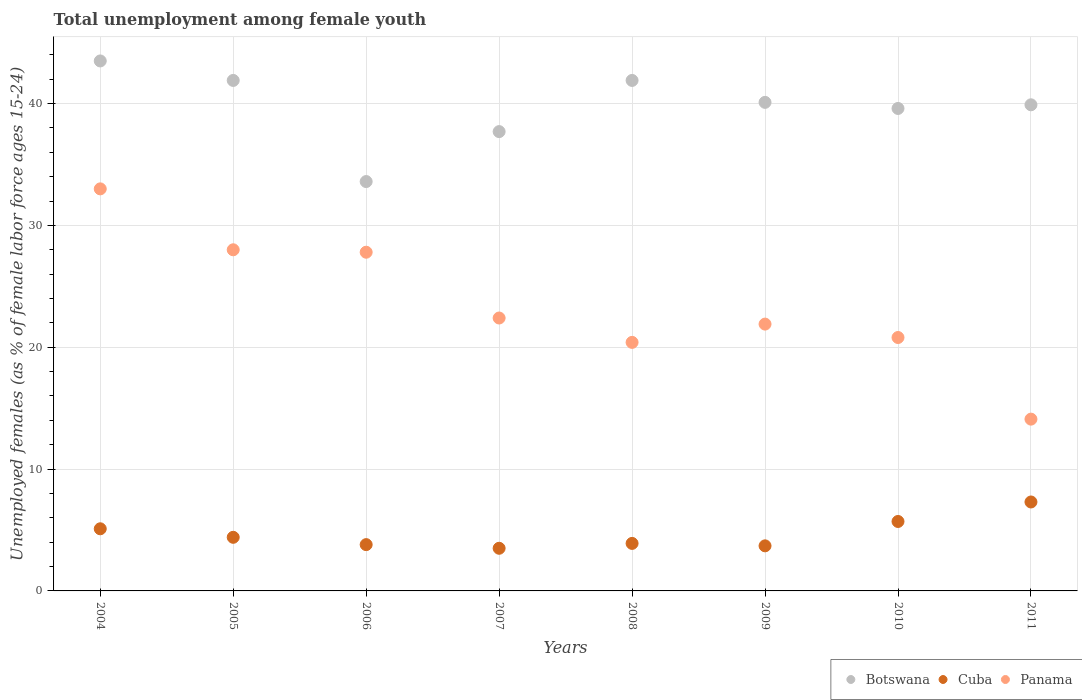How many different coloured dotlines are there?
Make the answer very short. 3. What is the percentage of unemployed females in in Cuba in 2011?
Make the answer very short. 7.3. In which year was the percentage of unemployed females in in Panama maximum?
Make the answer very short. 2004. What is the total percentage of unemployed females in in Panama in the graph?
Make the answer very short. 188.4. What is the difference between the percentage of unemployed females in in Cuba in 2004 and that in 2010?
Your answer should be very brief. -0.6. What is the difference between the percentage of unemployed females in in Cuba in 2009 and the percentage of unemployed females in in Panama in 2008?
Keep it short and to the point. -16.7. What is the average percentage of unemployed females in in Panama per year?
Offer a very short reply. 23.55. In the year 2006, what is the difference between the percentage of unemployed females in in Panama and percentage of unemployed females in in Botswana?
Provide a short and direct response. -5.8. In how many years, is the percentage of unemployed females in in Panama greater than 10 %?
Provide a succinct answer. 8. What is the ratio of the percentage of unemployed females in in Botswana in 2009 to that in 2010?
Provide a short and direct response. 1.01. Is the percentage of unemployed females in in Panama in 2007 less than that in 2009?
Offer a terse response. No. What is the difference between the highest and the second highest percentage of unemployed females in in Cuba?
Your answer should be very brief. 1.6. What is the difference between the highest and the lowest percentage of unemployed females in in Cuba?
Your answer should be very brief. 3.8. Is the sum of the percentage of unemployed females in in Botswana in 2006 and 2010 greater than the maximum percentage of unemployed females in in Panama across all years?
Provide a short and direct response. Yes. Does the percentage of unemployed females in in Botswana monotonically increase over the years?
Offer a very short reply. No. Is the percentage of unemployed females in in Botswana strictly greater than the percentage of unemployed females in in Panama over the years?
Make the answer very short. Yes. Is the percentage of unemployed females in in Panama strictly less than the percentage of unemployed females in in Botswana over the years?
Provide a succinct answer. Yes. How many dotlines are there?
Keep it short and to the point. 3. How many years are there in the graph?
Your answer should be compact. 8. Are the values on the major ticks of Y-axis written in scientific E-notation?
Your answer should be very brief. No. Does the graph contain any zero values?
Your answer should be very brief. No. Where does the legend appear in the graph?
Provide a short and direct response. Bottom right. How many legend labels are there?
Your response must be concise. 3. How are the legend labels stacked?
Ensure brevity in your answer.  Horizontal. What is the title of the graph?
Your response must be concise. Total unemployment among female youth. What is the label or title of the X-axis?
Ensure brevity in your answer.  Years. What is the label or title of the Y-axis?
Ensure brevity in your answer.  Unemployed females (as % of female labor force ages 15-24). What is the Unemployed females (as % of female labor force ages 15-24) of Botswana in 2004?
Ensure brevity in your answer.  43.5. What is the Unemployed females (as % of female labor force ages 15-24) of Cuba in 2004?
Your answer should be very brief. 5.1. What is the Unemployed females (as % of female labor force ages 15-24) in Panama in 2004?
Provide a succinct answer. 33. What is the Unemployed females (as % of female labor force ages 15-24) in Botswana in 2005?
Give a very brief answer. 41.9. What is the Unemployed females (as % of female labor force ages 15-24) in Cuba in 2005?
Your answer should be very brief. 4.4. What is the Unemployed females (as % of female labor force ages 15-24) in Panama in 2005?
Your answer should be compact. 28. What is the Unemployed females (as % of female labor force ages 15-24) of Botswana in 2006?
Your answer should be compact. 33.6. What is the Unemployed females (as % of female labor force ages 15-24) in Cuba in 2006?
Give a very brief answer. 3.8. What is the Unemployed females (as % of female labor force ages 15-24) of Panama in 2006?
Make the answer very short. 27.8. What is the Unemployed females (as % of female labor force ages 15-24) of Botswana in 2007?
Offer a terse response. 37.7. What is the Unemployed females (as % of female labor force ages 15-24) of Panama in 2007?
Make the answer very short. 22.4. What is the Unemployed females (as % of female labor force ages 15-24) in Botswana in 2008?
Ensure brevity in your answer.  41.9. What is the Unemployed females (as % of female labor force ages 15-24) in Cuba in 2008?
Your answer should be very brief. 3.9. What is the Unemployed females (as % of female labor force ages 15-24) of Panama in 2008?
Give a very brief answer. 20.4. What is the Unemployed females (as % of female labor force ages 15-24) of Botswana in 2009?
Your response must be concise. 40.1. What is the Unemployed females (as % of female labor force ages 15-24) in Cuba in 2009?
Provide a short and direct response. 3.7. What is the Unemployed females (as % of female labor force ages 15-24) of Panama in 2009?
Make the answer very short. 21.9. What is the Unemployed females (as % of female labor force ages 15-24) in Botswana in 2010?
Provide a succinct answer. 39.6. What is the Unemployed females (as % of female labor force ages 15-24) in Cuba in 2010?
Provide a succinct answer. 5.7. What is the Unemployed females (as % of female labor force ages 15-24) in Panama in 2010?
Your response must be concise. 20.8. What is the Unemployed females (as % of female labor force ages 15-24) of Botswana in 2011?
Keep it short and to the point. 39.9. What is the Unemployed females (as % of female labor force ages 15-24) in Cuba in 2011?
Offer a terse response. 7.3. What is the Unemployed females (as % of female labor force ages 15-24) of Panama in 2011?
Provide a short and direct response. 14.1. Across all years, what is the maximum Unemployed females (as % of female labor force ages 15-24) in Botswana?
Your answer should be very brief. 43.5. Across all years, what is the maximum Unemployed females (as % of female labor force ages 15-24) of Cuba?
Give a very brief answer. 7.3. Across all years, what is the maximum Unemployed females (as % of female labor force ages 15-24) of Panama?
Your answer should be compact. 33. Across all years, what is the minimum Unemployed females (as % of female labor force ages 15-24) in Botswana?
Your response must be concise. 33.6. Across all years, what is the minimum Unemployed females (as % of female labor force ages 15-24) of Panama?
Give a very brief answer. 14.1. What is the total Unemployed females (as % of female labor force ages 15-24) of Botswana in the graph?
Keep it short and to the point. 318.2. What is the total Unemployed females (as % of female labor force ages 15-24) in Cuba in the graph?
Your response must be concise. 37.4. What is the total Unemployed females (as % of female labor force ages 15-24) of Panama in the graph?
Your answer should be very brief. 188.4. What is the difference between the Unemployed females (as % of female labor force ages 15-24) in Panama in 2004 and that in 2005?
Keep it short and to the point. 5. What is the difference between the Unemployed females (as % of female labor force ages 15-24) of Botswana in 2004 and that in 2006?
Your response must be concise. 9.9. What is the difference between the Unemployed females (as % of female labor force ages 15-24) in Cuba in 2004 and that in 2006?
Give a very brief answer. 1.3. What is the difference between the Unemployed females (as % of female labor force ages 15-24) in Botswana in 2004 and that in 2007?
Give a very brief answer. 5.8. What is the difference between the Unemployed females (as % of female labor force ages 15-24) in Cuba in 2004 and that in 2007?
Provide a short and direct response. 1.6. What is the difference between the Unemployed females (as % of female labor force ages 15-24) in Botswana in 2004 and that in 2008?
Offer a very short reply. 1.6. What is the difference between the Unemployed females (as % of female labor force ages 15-24) in Panama in 2004 and that in 2008?
Your answer should be very brief. 12.6. What is the difference between the Unemployed females (as % of female labor force ages 15-24) in Cuba in 2004 and that in 2009?
Your response must be concise. 1.4. What is the difference between the Unemployed females (as % of female labor force ages 15-24) of Cuba in 2004 and that in 2010?
Provide a short and direct response. -0.6. What is the difference between the Unemployed females (as % of female labor force ages 15-24) of Panama in 2004 and that in 2010?
Give a very brief answer. 12.2. What is the difference between the Unemployed females (as % of female labor force ages 15-24) of Botswana in 2004 and that in 2011?
Your response must be concise. 3.6. What is the difference between the Unemployed females (as % of female labor force ages 15-24) in Panama in 2005 and that in 2006?
Provide a succinct answer. 0.2. What is the difference between the Unemployed females (as % of female labor force ages 15-24) of Cuba in 2005 and that in 2007?
Keep it short and to the point. 0.9. What is the difference between the Unemployed females (as % of female labor force ages 15-24) in Panama in 2005 and that in 2007?
Ensure brevity in your answer.  5.6. What is the difference between the Unemployed females (as % of female labor force ages 15-24) of Cuba in 2005 and that in 2009?
Ensure brevity in your answer.  0.7. What is the difference between the Unemployed females (as % of female labor force ages 15-24) of Panama in 2005 and that in 2009?
Provide a succinct answer. 6.1. What is the difference between the Unemployed females (as % of female labor force ages 15-24) of Cuba in 2005 and that in 2010?
Keep it short and to the point. -1.3. What is the difference between the Unemployed females (as % of female labor force ages 15-24) in Panama in 2005 and that in 2010?
Your answer should be very brief. 7.2. What is the difference between the Unemployed females (as % of female labor force ages 15-24) in Botswana in 2005 and that in 2011?
Your answer should be very brief. 2. What is the difference between the Unemployed females (as % of female labor force ages 15-24) in Panama in 2005 and that in 2011?
Provide a short and direct response. 13.9. What is the difference between the Unemployed females (as % of female labor force ages 15-24) of Botswana in 2006 and that in 2007?
Make the answer very short. -4.1. What is the difference between the Unemployed females (as % of female labor force ages 15-24) of Cuba in 2006 and that in 2007?
Make the answer very short. 0.3. What is the difference between the Unemployed females (as % of female labor force ages 15-24) in Botswana in 2006 and that in 2008?
Give a very brief answer. -8.3. What is the difference between the Unemployed females (as % of female labor force ages 15-24) in Panama in 2006 and that in 2008?
Make the answer very short. 7.4. What is the difference between the Unemployed females (as % of female labor force ages 15-24) in Panama in 2006 and that in 2009?
Make the answer very short. 5.9. What is the difference between the Unemployed females (as % of female labor force ages 15-24) of Cuba in 2006 and that in 2010?
Offer a terse response. -1.9. What is the difference between the Unemployed females (as % of female labor force ages 15-24) in Panama in 2006 and that in 2010?
Ensure brevity in your answer.  7. What is the difference between the Unemployed females (as % of female labor force ages 15-24) of Cuba in 2006 and that in 2011?
Ensure brevity in your answer.  -3.5. What is the difference between the Unemployed females (as % of female labor force ages 15-24) of Panama in 2006 and that in 2011?
Offer a terse response. 13.7. What is the difference between the Unemployed females (as % of female labor force ages 15-24) of Botswana in 2007 and that in 2008?
Offer a very short reply. -4.2. What is the difference between the Unemployed females (as % of female labor force ages 15-24) of Cuba in 2007 and that in 2008?
Your response must be concise. -0.4. What is the difference between the Unemployed females (as % of female labor force ages 15-24) in Botswana in 2007 and that in 2009?
Your answer should be very brief. -2.4. What is the difference between the Unemployed females (as % of female labor force ages 15-24) of Cuba in 2007 and that in 2009?
Offer a very short reply. -0.2. What is the difference between the Unemployed females (as % of female labor force ages 15-24) in Panama in 2007 and that in 2010?
Give a very brief answer. 1.6. What is the difference between the Unemployed females (as % of female labor force ages 15-24) of Botswana in 2007 and that in 2011?
Make the answer very short. -2.2. What is the difference between the Unemployed females (as % of female labor force ages 15-24) of Cuba in 2007 and that in 2011?
Your response must be concise. -3.8. What is the difference between the Unemployed females (as % of female labor force ages 15-24) of Botswana in 2008 and that in 2009?
Make the answer very short. 1.8. What is the difference between the Unemployed females (as % of female labor force ages 15-24) in Cuba in 2008 and that in 2009?
Provide a succinct answer. 0.2. What is the difference between the Unemployed females (as % of female labor force ages 15-24) in Panama in 2008 and that in 2009?
Offer a terse response. -1.5. What is the difference between the Unemployed females (as % of female labor force ages 15-24) in Botswana in 2008 and that in 2010?
Make the answer very short. 2.3. What is the difference between the Unemployed females (as % of female labor force ages 15-24) in Cuba in 2008 and that in 2011?
Ensure brevity in your answer.  -3.4. What is the difference between the Unemployed females (as % of female labor force ages 15-24) in Panama in 2008 and that in 2011?
Ensure brevity in your answer.  6.3. What is the difference between the Unemployed females (as % of female labor force ages 15-24) in Botswana in 2009 and that in 2010?
Provide a short and direct response. 0.5. What is the difference between the Unemployed females (as % of female labor force ages 15-24) of Cuba in 2009 and that in 2010?
Provide a short and direct response. -2. What is the difference between the Unemployed females (as % of female labor force ages 15-24) in Panama in 2009 and that in 2010?
Offer a very short reply. 1.1. What is the difference between the Unemployed females (as % of female labor force ages 15-24) in Botswana in 2009 and that in 2011?
Keep it short and to the point. 0.2. What is the difference between the Unemployed females (as % of female labor force ages 15-24) in Cuba in 2009 and that in 2011?
Ensure brevity in your answer.  -3.6. What is the difference between the Unemployed females (as % of female labor force ages 15-24) in Panama in 2009 and that in 2011?
Provide a short and direct response. 7.8. What is the difference between the Unemployed females (as % of female labor force ages 15-24) in Botswana in 2004 and the Unemployed females (as % of female labor force ages 15-24) in Cuba in 2005?
Ensure brevity in your answer.  39.1. What is the difference between the Unemployed females (as % of female labor force ages 15-24) in Cuba in 2004 and the Unemployed females (as % of female labor force ages 15-24) in Panama in 2005?
Ensure brevity in your answer.  -22.9. What is the difference between the Unemployed females (as % of female labor force ages 15-24) in Botswana in 2004 and the Unemployed females (as % of female labor force ages 15-24) in Cuba in 2006?
Keep it short and to the point. 39.7. What is the difference between the Unemployed females (as % of female labor force ages 15-24) of Cuba in 2004 and the Unemployed females (as % of female labor force ages 15-24) of Panama in 2006?
Provide a succinct answer. -22.7. What is the difference between the Unemployed females (as % of female labor force ages 15-24) in Botswana in 2004 and the Unemployed females (as % of female labor force ages 15-24) in Panama in 2007?
Offer a very short reply. 21.1. What is the difference between the Unemployed females (as % of female labor force ages 15-24) of Cuba in 2004 and the Unemployed females (as % of female labor force ages 15-24) of Panama in 2007?
Offer a terse response. -17.3. What is the difference between the Unemployed females (as % of female labor force ages 15-24) of Botswana in 2004 and the Unemployed females (as % of female labor force ages 15-24) of Cuba in 2008?
Provide a succinct answer. 39.6. What is the difference between the Unemployed females (as % of female labor force ages 15-24) of Botswana in 2004 and the Unemployed females (as % of female labor force ages 15-24) of Panama in 2008?
Keep it short and to the point. 23.1. What is the difference between the Unemployed females (as % of female labor force ages 15-24) of Cuba in 2004 and the Unemployed females (as % of female labor force ages 15-24) of Panama in 2008?
Offer a terse response. -15.3. What is the difference between the Unemployed females (as % of female labor force ages 15-24) in Botswana in 2004 and the Unemployed females (as % of female labor force ages 15-24) in Cuba in 2009?
Provide a short and direct response. 39.8. What is the difference between the Unemployed females (as % of female labor force ages 15-24) in Botswana in 2004 and the Unemployed females (as % of female labor force ages 15-24) in Panama in 2009?
Provide a succinct answer. 21.6. What is the difference between the Unemployed females (as % of female labor force ages 15-24) in Cuba in 2004 and the Unemployed females (as % of female labor force ages 15-24) in Panama in 2009?
Offer a very short reply. -16.8. What is the difference between the Unemployed females (as % of female labor force ages 15-24) of Botswana in 2004 and the Unemployed females (as % of female labor force ages 15-24) of Cuba in 2010?
Ensure brevity in your answer.  37.8. What is the difference between the Unemployed females (as % of female labor force ages 15-24) of Botswana in 2004 and the Unemployed females (as % of female labor force ages 15-24) of Panama in 2010?
Give a very brief answer. 22.7. What is the difference between the Unemployed females (as % of female labor force ages 15-24) of Cuba in 2004 and the Unemployed females (as % of female labor force ages 15-24) of Panama in 2010?
Keep it short and to the point. -15.7. What is the difference between the Unemployed females (as % of female labor force ages 15-24) of Botswana in 2004 and the Unemployed females (as % of female labor force ages 15-24) of Cuba in 2011?
Ensure brevity in your answer.  36.2. What is the difference between the Unemployed females (as % of female labor force ages 15-24) of Botswana in 2004 and the Unemployed females (as % of female labor force ages 15-24) of Panama in 2011?
Provide a succinct answer. 29.4. What is the difference between the Unemployed females (as % of female labor force ages 15-24) in Botswana in 2005 and the Unemployed females (as % of female labor force ages 15-24) in Cuba in 2006?
Make the answer very short. 38.1. What is the difference between the Unemployed females (as % of female labor force ages 15-24) of Cuba in 2005 and the Unemployed females (as % of female labor force ages 15-24) of Panama in 2006?
Ensure brevity in your answer.  -23.4. What is the difference between the Unemployed females (as % of female labor force ages 15-24) of Botswana in 2005 and the Unemployed females (as % of female labor force ages 15-24) of Cuba in 2007?
Offer a very short reply. 38.4. What is the difference between the Unemployed females (as % of female labor force ages 15-24) in Botswana in 2005 and the Unemployed females (as % of female labor force ages 15-24) in Panama in 2007?
Give a very brief answer. 19.5. What is the difference between the Unemployed females (as % of female labor force ages 15-24) in Botswana in 2005 and the Unemployed females (as % of female labor force ages 15-24) in Cuba in 2008?
Offer a terse response. 38. What is the difference between the Unemployed females (as % of female labor force ages 15-24) of Botswana in 2005 and the Unemployed females (as % of female labor force ages 15-24) of Panama in 2008?
Your response must be concise. 21.5. What is the difference between the Unemployed females (as % of female labor force ages 15-24) of Cuba in 2005 and the Unemployed females (as % of female labor force ages 15-24) of Panama in 2008?
Provide a short and direct response. -16. What is the difference between the Unemployed females (as % of female labor force ages 15-24) in Botswana in 2005 and the Unemployed females (as % of female labor force ages 15-24) in Cuba in 2009?
Keep it short and to the point. 38.2. What is the difference between the Unemployed females (as % of female labor force ages 15-24) of Cuba in 2005 and the Unemployed females (as % of female labor force ages 15-24) of Panama in 2009?
Keep it short and to the point. -17.5. What is the difference between the Unemployed females (as % of female labor force ages 15-24) in Botswana in 2005 and the Unemployed females (as % of female labor force ages 15-24) in Cuba in 2010?
Offer a terse response. 36.2. What is the difference between the Unemployed females (as % of female labor force ages 15-24) in Botswana in 2005 and the Unemployed females (as % of female labor force ages 15-24) in Panama in 2010?
Ensure brevity in your answer.  21.1. What is the difference between the Unemployed females (as % of female labor force ages 15-24) of Cuba in 2005 and the Unemployed females (as % of female labor force ages 15-24) of Panama in 2010?
Offer a very short reply. -16.4. What is the difference between the Unemployed females (as % of female labor force ages 15-24) in Botswana in 2005 and the Unemployed females (as % of female labor force ages 15-24) in Cuba in 2011?
Give a very brief answer. 34.6. What is the difference between the Unemployed females (as % of female labor force ages 15-24) of Botswana in 2005 and the Unemployed females (as % of female labor force ages 15-24) of Panama in 2011?
Provide a succinct answer. 27.8. What is the difference between the Unemployed females (as % of female labor force ages 15-24) of Botswana in 2006 and the Unemployed females (as % of female labor force ages 15-24) of Cuba in 2007?
Provide a short and direct response. 30.1. What is the difference between the Unemployed females (as % of female labor force ages 15-24) in Botswana in 2006 and the Unemployed females (as % of female labor force ages 15-24) in Panama in 2007?
Your answer should be very brief. 11.2. What is the difference between the Unemployed females (as % of female labor force ages 15-24) in Cuba in 2006 and the Unemployed females (as % of female labor force ages 15-24) in Panama in 2007?
Offer a terse response. -18.6. What is the difference between the Unemployed females (as % of female labor force ages 15-24) in Botswana in 2006 and the Unemployed females (as % of female labor force ages 15-24) in Cuba in 2008?
Keep it short and to the point. 29.7. What is the difference between the Unemployed females (as % of female labor force ages 15-24) of Botswana in 2006 and the Unemployed females (as % of female labor force ages 15-24) of Panama in 2008?
Provide a succinct answer. 13.2. What is the difference between the Unemployed females (as % of female labor force ages 15-24) of Cuba in 2006 and the Unemployed females (as % of female labor force ages 15-24) of Panama in 2008?
Ensure brevity in your answer.  -16.6. What is the difference between the Unemployed females (as % of female labor force ages 15-24) of Botswana in 2006 and the Unemployed females (as % of female labor force ages 15-24) of Cuba in 2009?
Make the answer very short. 29.9. What is the difference between the Unemployed females (as % of female labor force ages 15-24) in Botswana in 2006 and the Unemployed females (as % of female labor force ages 15-24) in Panama in 2009?
Your answer should be compact. 11.7. What is the difference between the Unemployed females (as % of female labor force ages 15-24) of Cuba in 2006 and the Unemployed females (as % of female labor force ages 15-24) of Panama in 2009?
Give a very brief answer. -18.1. What is the difference between the Unemployed females (as % of female labor force ages 15-24) of Botswana in 2006 and the Unemployed females (as % of female labor force ages 15-24) of Cuba in 2010?
Provide a succinct answer. 27.9. What is the difference between the Unemployed females (as % of female labor force ages 15-24) in Botswana in 2006 and the Unemployed females (as % of female labor force ages 15-24) in Panama in 2010?
Offer a terse response. 12.8. What is the difference between the Unemployed females (as % of female labor force ages 15-24) in Cuba in 2006 and the Unemployed females (as % of female labor force ages 15-24) in Panama in 2010?
Provide a succinct answer. -17. What is the difference between the Unemployed females (as % of female labor force ages 15-24) in Botswana in 2006 and the Unemployed females (as % of female labor force ages 15-24) in Cuba in 2011?
Your response must be concise. 26.3. What is the difference between the Unemployed females (as % of female labor force ages 15-24) in Botswana in 2006 and the Unemployed females (as % of female labor force ages 15-24) in Panama in 2011?
Offer a very short reply. 19.5. What is the difference between the Unemployed females (as % of female labor force ages 15-24) in Cuba in 2006 and the Unemployed females (as % of female labor force ages 15-24) in Panama in 2011?
Your answer should be very brief. -10.3. What is the difference between the Unemployed females (as % of female labor force ages 15-24) of Botswana in 2007 and the Unemployed females (as % of female labor force ages 15-24) of Cuba in 2008?
Make the answer very short. 33.8. What is the difference between the Unemployed females (as % of female labor force ages 15-24) of Botswana in 2007 and the Unemployed females (as % of female labor force ages 15-24) of Panama in 2008?
Your answer should be compact. 17.3. What is the difference between the Unemployed females (as % of female labor force ages 15-24) of Cuba in 2007 and the Unemployed females (as % of female labor force ages 15-24) of Panama in 2008?
Give a very brief answer. -16.9. What is the difference between the Unemployed females (as % of female labor force ages 15-24) in Botswana in 2007 and the Unemployed females (as % of female labor force ages 15-24) in Cuba in 2009?
Provide a short and direct response. 34. What is the difference between the Unemployed females (as % of female labor force ages 15-24) in Cuba in 2007 and the Unemployed females (as % of female labor force ages 15-24) in Panama in 2009?
Ensure brevity in your answer.  -18.4. What is the difference between the Unemployed females (as % of female labor force ages 15-24) of Botswana in 2007 and the Unemployed females (as % of female labor force ages 15-24) of Cuba in 2010?
Give a very brief answer. 32. What is the difference between the Unemployed females (as % of female labor force ages 15-24) of Cuba in 2007 and the Unemployed females (as % of female labor force ages 15-24) of Panama in 2010?
Provide a succinct answer. -17.3. What is the difference between the Unemployed females (as % of female labor force ages 15-24) in Botswana in 2007 and the Unemployed females (as % of female labor force ages 15-24) in Cuba in 2011?
Offer a terse response. 30.4. What is the difference between the Unemployed females (as % of female labor force ages 15-24) of Botswana in 2007 and the Unemployed females (as % of female labor force ages 15-24) of Panama in 2011?
Offer a terse response. 23.6. What is the difference between the Unemployed females (as % of female labor force ages 15-24) in Cuba in 2007 and the Unemployed females (as % of female labor force ages 15-24) in Panama in 2011?
Provide a short and direct response. -10.6. What is the difference between the Unemployed females (as % of female labor force ages 15-24) in Botswana in 2008 and the Unemployed females (as % of female labor force ages 15-24) in Cuba in 2009?
Your response must be concise. 38.2. What is the difference between the Unemployed females (as % of female labor force ages 15-24) in Cuba in 2008 and the Unemployed females (as % of female labor force ages 15-24) in Panama in 2009?
Keep it short and to the point. -18. What is the difference between the Unemployed females (as % of female labor force ages 15-24) in Botswana in 2008 and the Unemployed females (as % of female labor force ages 15-24) in Cuba in 2010?
Ensure brevity in your answer.  36.2. What is the difference between the Unemployed females (as % of female labor force ages 15-24) in Botswana in 2008 and the Unemployed females (as % of female labor force ages 15-24) in Panama in 2010?
Offer a terse response. 21.1. What is the difference between the Unemployed females (as % of female labor force ages 15-24) in Cuba in 2008 and the Unemployed females (as % of female labor force ages 15-24) in Panama in 2010?
Give a very brief answer. -16.9. What is the difference between the Unemployed females (as % of female labor force ages 15-24) in Botswana in 2008 and the Unemployed females (as % of female labor force ages 15-24) in Cuba in 2011?
Your answer should be compact. 34.6. What is the difference between the Unemployed females (as % of female labor force ages 15-24) of Botswana in 2008 and the Unemployed females (as % of female labor force ages 15-24) of Panama in 2011?
Offer a terse response. 27.8. What is the difference between the Unemployed females (as % of female labor force ages 15-24) in Cuba in 2008 and the Unemployed females (as % of female labor force ages 15-24) in Panama in 2011?
Your answer should be compact. -10.2. What is the difference between the Unemployed females (as % of female labor force ages 15-24) in Botswana in 2009 and the Unemployed females (as % of female labor force ages 15-24) in Cuba in 2010?
Offer a terse response. 34.4. What is the difference between the Unemployed females (as % of female labor force ages 15-24) of Botswana in 2009 and the Unemployed females (as % of female labor force ages 15-24) of Panama in 2010?
Make the answer very short. 19.3. What is the difference between the Unemployed females (as % of female labor force ages 15-24) of Cuba in 2009 and the Unemployed females (as % of female labor force ages 15-24) of Panama in 2010?
Offer a very short reply. -17.1. What is the difference between the Unemployed females (as % of female labor force ages 15-24) of Botswana in 2009 and the Unemployed females (as % of female labor force ages 15-24) of Cuba in 2011?
Provide a succinct answer. 32.8. What is the difference between the Unemployed females (as % of female labor force ages 15-24) in Botswana in 2009 and the Unemployed females (as % of female labor force ages 15-24) in Panama in 2011?
Keep it short and to the point. 26. What is the difference between the Unemployed females (as % of female labor force ages 15-24) of Cuba in 2009 and the Unemployed females (as % of female labor force ages 15-24) of Panama in 2011?
Your answer should be compact. -10.4. What is the difference between the Unemployed females (as % of female labor force ages 15-24) in Botswana in 2010 and the Unemployed females (as % of female labor force ages 15-24) in Cuba in 2011?
Provide a short and direct response. 32.3. What is the difference between the Unemployed females (as % of female labor force ages 15-24) of Botswana in 2010 and the Unemployed females (as % of female labor force ages 15-24) of Panama in 2011?
Your answer should be compact. 25.5. What is the average Unemployed females (as % of female labor force ages 15-24) in Botswana per year?
Provide a short and direct response. 39.77. What is the average Unemployed females (as % of female labor force ages 15-24) of Cuba per year?
Make the answer very short. 4.67. What is the average Unemployed females (as % of female labor force ages 15-24) of Panama per year?
Offer a terse response. 23.55. In the year 2004, what is the difference between the Unemployed females (as % of female labor force ages 15-24) in Botswana and Unemployed females (as % of female labor force ages 15-24) in Cuba?
Provide a short and direct response. 38.4. In the year 2004, what is the difference between the Unemployed females (as % of female labor force ages 15-24) of Cuba and Unemployed females (as % of female labor force ages 15-24) of Panama?
Offer a terse response. -27.9. In the year 2005, what is the difference between the Unemployed females (as % of female labor force ages 15-24) in Botswana and Unemployed females (as % of female labor force ages 15-24) in Cuba?
Provide a short and direct response. 37.5. In the year 2005, what is the difference between the Unemployed females (as % of female labor force ages 15-24) of Botswana and Unemployed females (as % of female labor force ages 15-24) of Panama?
Your answer should be very brief. 13.9. In the year 2005, what is the difference between the Unemployed females (as % of female labor force ages 15-24) of Cuba and Unemployed females (as % of female labor force ages 15-24) of Panama?
Your response must be concise. -23.6. In the year 2006, what is the difference between the Unemployed females (as % of female labor force ages 15-24) of Botswana and Unemployed females (as % of female labor force ages 15-24) of Cuba?
Your answer should be very brief. 29.8. In the year 2006, what is the difference between the Unemployed females (as % of female labor force ages 15-24) in Botswana and Unemployed females (as % of female labor force ages 15-24) in Panama?
Your answer should be very brief. 5.8. In the year 2006, what is the difference between the Unemployed females (as % of female labor force ages 15-24) in Cuba and Unemployed females (as % of female labor force ages 15-24) in Panama?
Offer a terse response. -24. In the year 2007, what is the difference between the Unemployed females (as % of female labor force ages 15-24) of Botswana and Unemployed females (as % of female labor force ages 15-24) of Cuba?
Give a very brief answer. 34.2. In the year 2007, what is the difference between the Unemployed females (as % of female labor force ages 15-24) of Botswana and Unemployed females (as % of female labor force ages 15-24) of Panama?
Your response must be concise. 15.3. In the year 2007, what is the difference between the Unemployed females (as % of female labor force ages 15-24) of Cuba and Unemployed females (as % of female labor force ages 15-24) of Panama?
Give a very brief answer. -18.9. In the year 2008, what is the difference between the Unemployed females (as % of female labor force ages 15-24) of Botswana and Unemployed females (as % of female labor force ages 15-24) of Panama?
Provide a short and direct response. 21.5. In the year 2008, what is the difference between the Unemployed females (as % of female labor force ages 15-24) of Cuba and Unemployed females (as % of female labor force ages 15-24) of Panama?
Provide a succinct answer. -16.5. In the year 2009, what is the difference between the Unemployed females (as % of female labor force ages 15-24) of Botswana and Unemployed females (as % of female labor force ages 15-24) of Cuba?
Offer a terse response. 36.4. In the year 2009, what is the difference between the Unemployed females (as % of female labor force ages 15-24) of Cuba and Unemployed females (as % of female labor force ages 15-24) of Panama?
Give a very brief answer. -18.2. In the year 2010, what is the difference between the Unemployed females (as % of female labor force ages 15-24) in Botswana and Unemployed females (as % of female labor force ages 15-24) in Cuba?
Provide a short and direct response. 33.9. In the year 2010, what is the difference between the Unemployed females (as % of female labor force ages 15-24) of Cuba and Unemployed females (as % of female labor force ages 15-24) of Panama?
Provide a short and direct response. -15.1. In the year 2011, what is the difference between the Unemployed females (as % of female labor force ages 15-24) of Botswana and Unemployed females (as % of female labor force ages 15-24) of Cuba?
Offer a terse response. 32.6. In the year 2011, what is the difference between the Unemployed females (as % of female labor force ages 15-24) of Botswana and Unemployed females (as % of female labor force ages 15-24) of Panama?
Provide a short and direct response. 25.8. In the year 2011, what is the difference between the Unemployed females (as % of female labor force ages 15-24) of Cuba and Unemployed females (as % of female labor force ages 15-24) of Panama?
Give a very brief answer. -6.8. What is the ratio of the Unemployed females (as % of female labor force ages 15-24) in Botswana in 2004 to that in 2005?
Keep it short and to the point. 1.04. What is the ratio of the Unemployed females (as % of female labor force ages 15-24) in Cuba in 2004 to that in 2005?
Provide a short and direct response. 1.16. What is the ratio of the Unemployed females (as % of female labor force ages 15-24) of Panama in 2004 to that in 2005?
Make the answer very short. 1.18. What is the ratio of the Unemployed females (as % of female labor force ages 15-24) in Botswana in 2004 to that in 2006?
Ensure brevity in your answer.  1.29. What is the ratio of the Unemployed females (as % of female labor force ages 15-24) in Cuba in 2004 to that in 2006?
Your response must be concise. 1.34. What is the ratio of the Unemployed females (as % of female labor force ages 15-24) of Panama in 2004 to that in 2006?
Provide a short and direct response. 1.19. What is the ratio of the Unemployed females (as % of female labor force ages 15-24) of Botswana in 2004 to that in 2007?
Provide a short and direct response. 1.15. What is the ratio of the Unemployed females (as % of female labor force ages 15-24) of Cuba in 2004 to that in 2007?
Provide a short and direct response. 1.46. What is the ratio of the Unemployed females (as % of female labor force ages 15-24) in Panama in 2004 to that in 2007?
Your answer should be very brief. 1.47. What is the ratio of the Unemployed females (as % of female labor force ages 15-24) of Botswana in 2004 to that in 2008?
Your answer should be very brief. 1.04. What is the ratio of the Unemployed females (as % of female labor force ages 15-24) in Cuba in 2004 to that in 2008?
Your response must be concise. 1.31. What is the ratio of the Unemployed females (as % of female labor force ages 15-24) in Panama in 2004 to that in 2008?
Make the answer very short. 1.62. What is the ratio of the Unemployed females (as % of female labor force ages 15-24) in Botswana in 2004 to that in 2009?
Your answer should be very brief. 1.08. What is the ratio of the Unemployed females (as % of female labor force ages 15-24) of Cuba in 2004 to that in 2009?
Give a very brief answer. 1.38. What is the ratio of the Unemployed females (as % of female labor force ages 15-24) in Panama in 2004 to that in 2009?
Keep it short and to the point. 1.51. What is the ratio of the Unemployed females (as % of female labor force ages 15-24) in Botswana in 2004 to that in 2010?
Offer a terse response. 1.1. What is the ratio of the Unemployed females (as % of female labor force ages 15-24) in Cuba in 2004 to that in 2010?
Your answer should be very brief. 0.89. What is the ratio of the Unemployed females (as % of female labor force ages 15-24) in Panama in 2004 to that in 2010?
Your answer should be compact. 1.59. What is the ratio of the Unemployed females (as % of female labor force ages 15-24) in Botswana in 2004 to that in 2011?
Give a very brief answer. 1.09. What is the ratio of the Unemployed females (as % of female labor force ages 15-24) in Cuba in 2004 to that in 2011?
Ensure brevity in your answer.  0.7. What is the ratio of the Unemployed females (as % of female labor force ages 15-24) of Panama in 2004 to that in 2011?
Your answer should be compact. 2.34. What is the ratio of the Unemployed females (as % of female labor force ages 15-24) in Botswana in 2005 to that in 2006?
Provide a succinct answer. 1.25. What is the ratio of the Unemployed females (as % of female labor force ages 15-24) of Cuba in 2005 to that in 2006?
Provide a short and direct response. 1.16. What is the ratio of the Unemployed females (as % of female labor force ages 15-24) in Botswana in 2005 to that in 2007?
Ensure brevity in your answer.  1.11. What is the ratio of the Unemployed females (as % of female labor force ages 15-24) of Cuba in 2005 to that in 2007?
Provide a short and direct response. 1.26. What is the ratio of the Unemployed females (as % of female labor force ages 15-24) in Panama in 2005 to that in 2007?
Your answer should be very brief. 1.25. What is the ratio of the Unemployed females (as % of female labor force ages 15-24) in Cuba in 2005 to that in 2008?
Keep it short and to the point. 1.13. What is the ratio of the Unemployed females (as % of female labor force ages 15-24) in Panama in 2005 to that in 2008?
Offer a terse response. 1.37. What is the ratio of the Unemployed females (as % of female labor force ages 15-24) in Botswana in 2005 to that in 2009?
Offer a terse response. 1.04. What is the ratio of the Unemployed females (as % of female labor force ages 15-24) of Cuba in 2005 to that in 2009?
Give a very brief answer. 1.19. What is the ratio of the Unemployed females (as % of female labor force ages 15-24) in Panama in 2005 to that in 2009?
Ensure brevity in your answer.  1.28. What is the ratio of the Unemployed females (as % of female labor force ages 15-24) in Botswana in 2005 to that in 2010?
Offer a very short reply. 1.06. What is the ratio of the Unemployed females (as % of female labor force ages 15-24) in Cuba in 2005 to that in 2010?
Provide a succinct answer. 0.77. What is the ratio of the Unemployed females (as % of female labor force ages 15-24) of Panama in 2005 to that in 2010?
Offer a terse response. 1.35. What is the ratio of the Unemployed females (as % of female labor force ages 15-24) in Botswana in 2005 to that in 2011?
Ensure brevity in your answer.  1.05. What is the ratio of the Unemployed females (as % of female labor force ages 15-24) in Cuba in 2005 to that in 2011?
Keep it short and to the point. 0.6. What is the ratio of the Unemployed females (as % of female labor force ages 15-24) of Panama in 2005 to that in 2011?
Offer a very short reply. 1.99. What is the ratio of the Unemployed females (as % of female labor force ages 15-24) in Botswana in 2006 to that in 2007?
Ensure brevity in your answer.  0.89. What is the ratio of the Unemployed females (as % of female labor force ages 15-24) in Cuba in 2006 to that in 2007?
Provide a short and direct response. 1.09. What is the ratio of the Unemployed females (as % of female labor force ages 15-24) of Panama in 2006 to that in 2007?
Give a very brief answer. 1.24. What is the ratio of the Unemployed females (as % of female labor force ages 15-24) in Botswana in 2006 to that in 2008?
Your answer should be compact. 0.8. What is the ratio of the Unemployed females (as % of female labor force ages 15-24) in Cuba in 2006 to that in 2008?
Your response must be concise. 0.97. What is the ratio of the Unemployed females (as % of female labor force ages 15-24) in Panama in 2006 to that in 2008?
Keep it short and to the point. 1.36. What is the ratio of the Unemployed females (as % of female labor force ages 15-24) in Botswana in 2006 to that in 2009?
Provide a short and direct response. 0.84. What is the ratio of the Unemployed females (as % of female labor force ages 15-24) in Cuba in 2006 to that in 2009?
Keep it short and to the point. 1.03. What is the ratio of the Unemployed females (as % of female labor force ages 15-24) of Panama in 2006 to that in 2009?
Offer a terse response. 1.27. What is the ratio of the Unemployed females (as % of female labor force ages 15-24) of Botswana in 2006 to that in 2010?
Provide a succinct answer. 0.85. What is the ratio of the Unemployed females (as % of female labor force ages 15-24) in Cuba in 2006 to that in 2010?
Provide a succinct answer. 0.67. What is the ratio of the Unemployed females (as % of female labor force ages 15-24) in Panama in 2006 to that in 2010?
Provide a short and direct response. 1.34. What is the ratio of the Unemployed females (as % of female labor force ages 15-24) of Botswana in 2006 to that in 2011?
Your response must be concise. 0.84. What is the ratio of the Unemployed females (as % of female labor force ages 15-24) of Cuba in 2006 to that in 2011?
Keep it short and to the point. 0.52. What is the ratio of the Unemployed females (as % of female labor force ages 15-24) in Panama in 2006 to that in 2011?
Keep it short and to the point. 1.97. What is the ratio of the Unemployed females (as % of female labor force ages 15-24) of Botswana in 2007 to that in 2008?
Provide a succinct answer. 0.9. What is the ratio of the Unemployed females (as % of female labor force ages 15-24) in Cuba in 2007 to that in 2008?
Ensure brevity in your answer.  0.9. What is the ratio of the Unemployed females (as % of female labor force ages 15-24) of Panama in 2007 to that in 2008?
Your response must be concise. 1.1. What is the ratio of the Unemployed females (as % of female labor force ages 15-24) of Botswana in 2007 to that in 2009?
Provide a short and direct response. 0.94. What is the ratio of the Unemployed females (as % of female labor force ages 15-24) of Cuba in 2007 to that in 2009?
Your answer should be very brief. 0.95. What is the ratio of the Unemployed females (as % of female labor force ages 15-24) of Panama in 2007 to that in 2009?
Your answer should be compact. 1.02. What is the ratio of the Unemployed females (as % of female labor force ages 15-24) in Botswana in 2007 to that in 2010?
Give a very brief answer. 0.95. What is the ratio of the Unemployed females (as % of female labor force ages 15-24) in Cuba in 2007 to that in 2010?
Provide a succinct answer. 0.61. What is the ratio of the Unemployed females (as % of female labor force ages 15-24) in Botswana in 2007 to that in 2011?
Keep it short and to the point. 0.94. What is the ratio of the Unemployed females (as % of female labor force ages 15-24) of Cuba in 2007 to that in 2011?
Make the answer very short. 0.48. What is the ratio of the Unemployed females (as % of female labor force ages 15-24) in Panama in 2007 to that in 2011?
Ensure brevity in your answer.  1.59. What is the ratio of the Unemployed females (as % of female labor force ages 15-24) in Botswana in 2008 to that in 2009?
Your answer should be very brief. 1.04. What is the ratio of the Unemployed females (as % of female labor force ages 15-24) of Cuba in 2008 to that in 2009?
Ensure brevity in your answer.  1.05. What is the ratio of the Unemployed females (as % of female labor force ages 15-24) in Panama in 2008 to that in 2009?
Make the answer very short. 0.93. What is the ratio of the Unemployed females (as % of female labor force ages 15-24) of Botswana in 2008 to that in 2010?
Offer a terse response. 1.06. What is the ratio of the Unemployed females (as % of female labor force ages 15-24) in Cuba in 2008 to that in 2010?
Ensure brevity in your answer.  0.68. What is the ratio of the Unemployed females (as % of female labor force ages 15-24) of Panama in 2008 to that in 2010?
Keep it short and to the point. 0.98. What is the ratio of the Unemployed females (as % of female labor force ages 15-24) in Botswana in 2008 to that in 2011?
Ensure brevity in your answer.  1.05. What is the ratio of the Unemployed females (as % of female labor force ages 15-24) in Cuba in 2008 to that in 2011?
Ensure brevity in your answer.  0.53. What is the ratio of the Unemployed females (as % of female labor force ages 15-24) in Panama in 2008 to that in 2011?
Offer a very short reply. 1.45. What is the ratio of the Unemployed females (as % of female labor force ages 15-24) in Botswana in 2009 to that in 2010?
Keep it short and to the point. 1.01. What is the ratio of the Unemployed females (as % of female labor force ages 15-24) in Cuba in 2009 to that in 2010?
Ensure brevity in your answer.  0.65. What is the ratio of the Unemployed females (as % of female labor force ages 15-24) in Panama in 2009 to that in 2010?
Offer a very short reply. 1.05. What is the ratio of the Unemployed females (as % of female labor force ages 15-24) in Cuba in 2009 to that in 2011?
Make the answer very short. 0.51. What is the ratio of the Unemployed females (as % of female labor force ages 15-24) of Panama in 2009 to that in 2011?
Provide a succinct answer. 1.55. What is the ratio of the Unemployed females (as % of female labor force ages 15-24) of Botswana in 2010 to that in 2011?
Your response must be concise. 0.99. What is the ratio of the Unemployed females (as % of female labor force ages 15-24) of Cuba in 2010 to that in 2011?
Make the answer very short. 0.78. What is the ratio of the Unemployed females (as % of female labor force ages 15-24) in Panama in 2010 to that in 2011?
Your answer should be very brief. 1.48. What is the difference between the highest and the second highest Unemployed females (as % of female labor force ages 15-24) in Panama?
Offer a terse response. 5. What is the difference between the highest and the lowest Unemployed females (as % of female labor force ages 15-24) in Botswana?
Your response must be concise. 9.9. What is the difference between the highest and the lowest Unemployed females (as % of female labor force ages 15-24) in Panama?
Give a very brief answer. 18.9. 